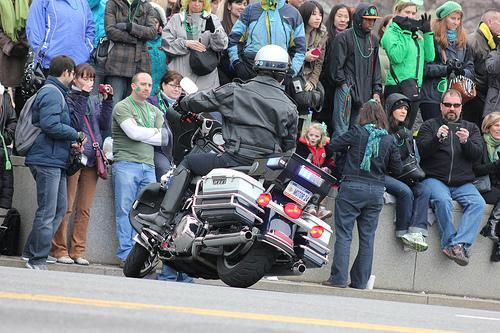Provide a brief description of the central focal point in the image. A motorcycle policeman is turning around amidst a crowd during a possible St. Patrick's Day parade. Provide a short, poetic description of the image. Amidst a sea of spectators, a policeman weaves his way, a whiff of St. Patrick's Day magic fills the air. In one sentence, summarize the main activity or event taking place in the picture. A policeman on a motorcycle is turning with spectators looking on, potentially at a St. Patrick's Day parade. Explain the atmosphere or emotion conveyed by the image in one sentence. The image portrays a festive atmosphere with people observing a motorcycle policeman during a possible parade. Describe the clothing and accessories of two prominent people in the image. A woman wears a blue scarf and a man is wearing a grey backpack, while observing the policeman on the motorcycle. What is the most noticeable action happening in the image? The motorcycle policeman turning around in the middle of the street is the most noticeable action. Select the three most dominant colors in the image and link them to the objects/people they are associated with. Green (four leaf clover on man's face, possible St. Patrick's Day theme), blue (woman's scarf), and gray (man's backpack). If this image were to be used for a news article, what would be an appropriate headline? St. Patrick's Day Parade Sees Policeman on Motorcycle Attracting Attention from Enthusiastic Onlookers Mention any specific elements in the image that could indicate a special event or occasion. Green four leaf clover on man's face, and crowd suggest a potential St. Patrick's Day parade. List the most prominent objects or people visible in the photo. Motorcycle policeman, emergency medical boxes, people sitting and standing, man with green face paint, woman in scarf. 